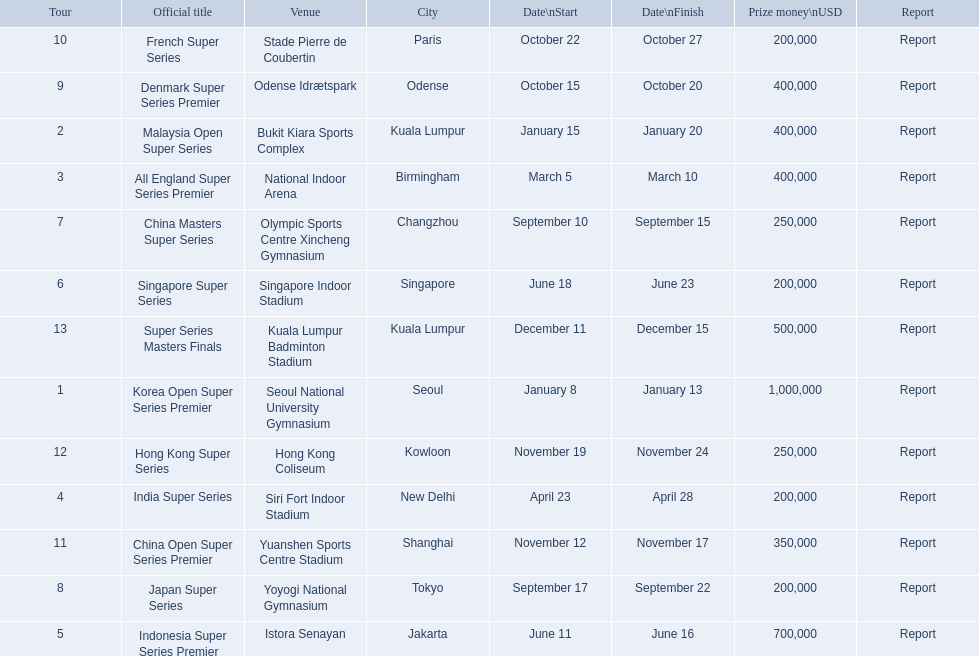What are all the tours? Korea Open Super Series Premier, Malaysia Open Super Series, All England Super Series Premier, India Super Series, Indonesia Super Series Premier, Singapore Super Series, China Masters Super Series, Japan Super Series, Denmark Super Series Premier, French Super Series, China Open Super Series Premier, Hong Kong Super Series, Super Series Masters Finals. What were the start dates of these tours? January 8, January 15, March 5, April 23, June 11, June 18, September 10, September 17, October 15, October 22, November 12, November 19, December 11. Of these, which is in december? December 11. Which tour started on this date? Super Series Masters Finals. 